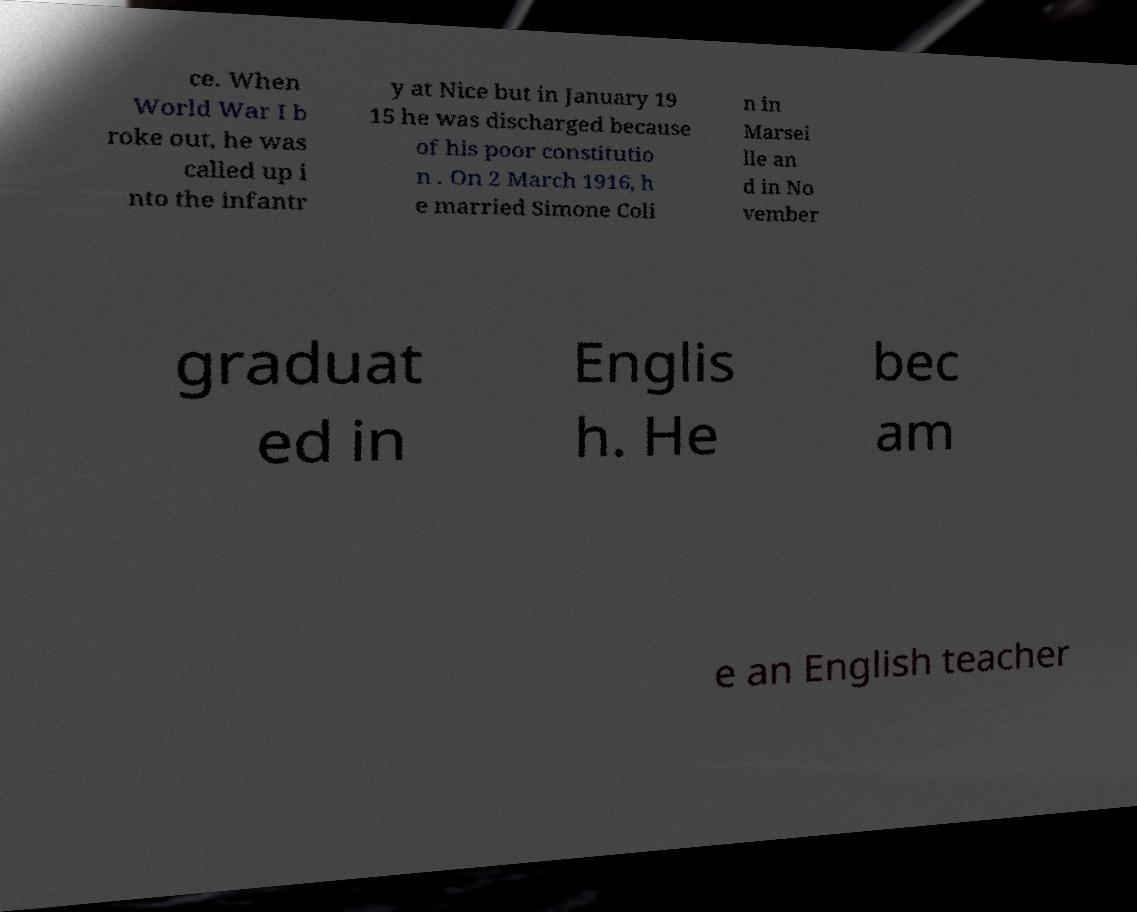Could you extract and type out the text from this image? ce. When World War I b roke out, he was called up i nto the infantr y at Nice but in January 19 15 he was discharged because of his poor constitutio n . On 2 March 1916, h e married Simone Coli n in Marsei lle an d in No vember graduat ed in Englis h. He bec am e an English teacher 